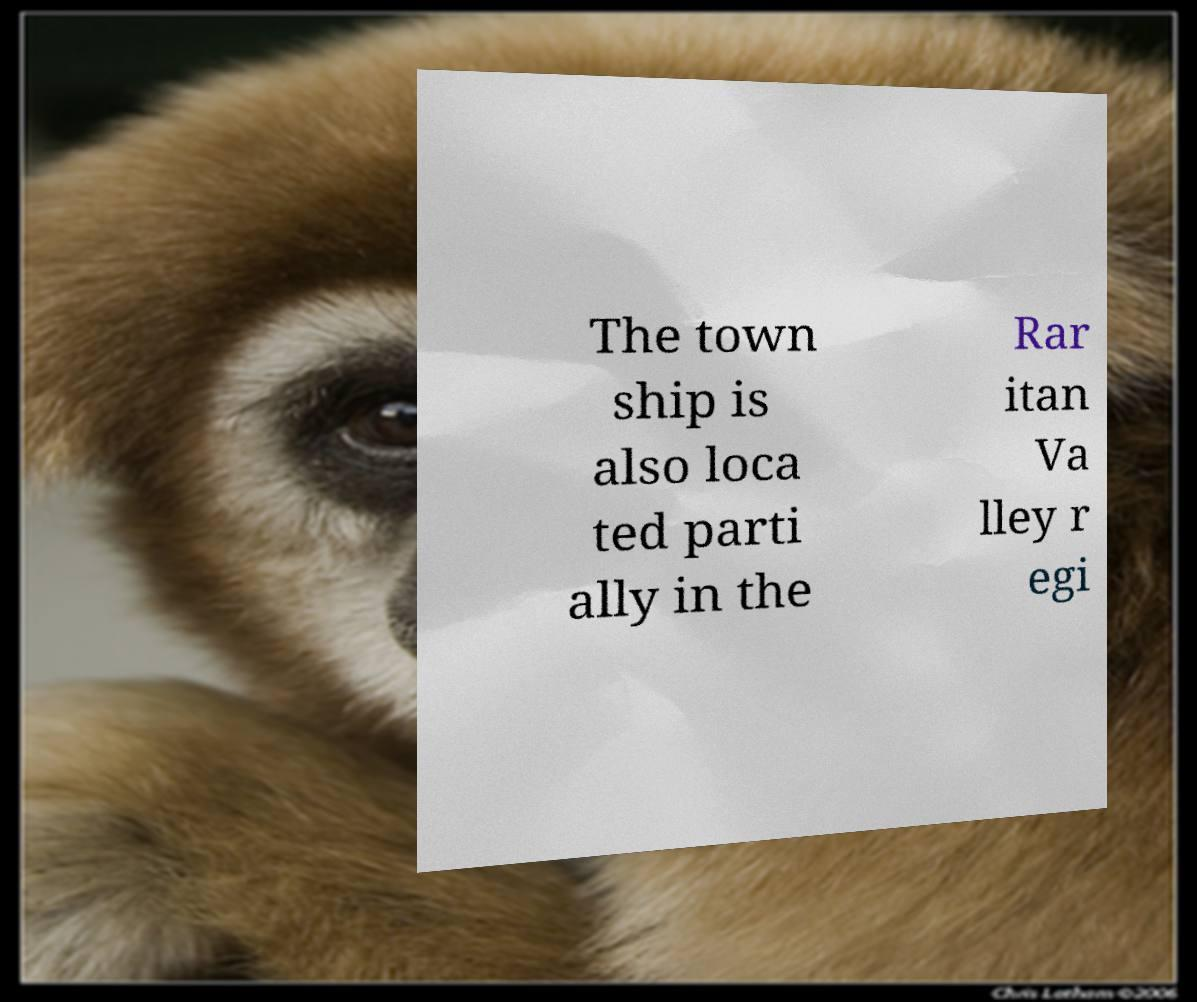Can you accurately transcribe the text from the provided image for me? The town ship is also loca ted parti ally in the Rar itan Va lley r egi 